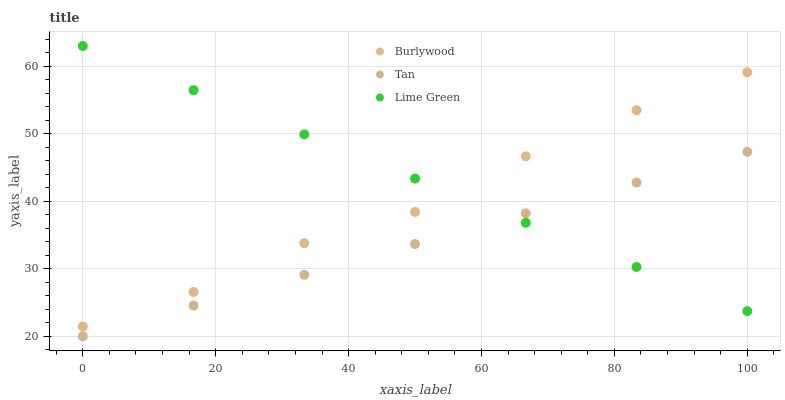Does Tan have the minimum area under the curve?
Answer yes or no. Yes. Does Lime Green have the maximum area under the curve?
Answer yes or no. Yes. Does Lime Green have the minimum area under the curve?
Answer yes or no. No. Does Tan have the maximum area under the curve?
Answer yes or no. No. Is Tan the smoothest?
Answer yes or no. Yes. Is Burlywood the roughest?
Answer yes or no. Yes. Is Lime Green the smoothest?
Answer yes or no. No. Is Lime Green the roughest?
Answer yes or no. No. Does Tan have the lowest value?
Answer yes or no. Yes. Does Lime Green have the lowest value?
Answer yes or no. No. Does Lime Green have the highest value?
Answer yes or no. Yes. Does Tan have the highest value?
Answer yes or no. No. Is Tan less than Burlywood?
Answer yes or no. Yes. Is Burlywood greater than Tan?
Answer yes or no. Yes. Does Tan intersect Lime Green?
Answer yes or no. Yes. Is Tan less than Lime Green?
Answer yes or no. No. Is Tan greater than Lime Green?
Answer yes or no. No. Does Tan intersect Burlywood?
Answer yes or no. No. 